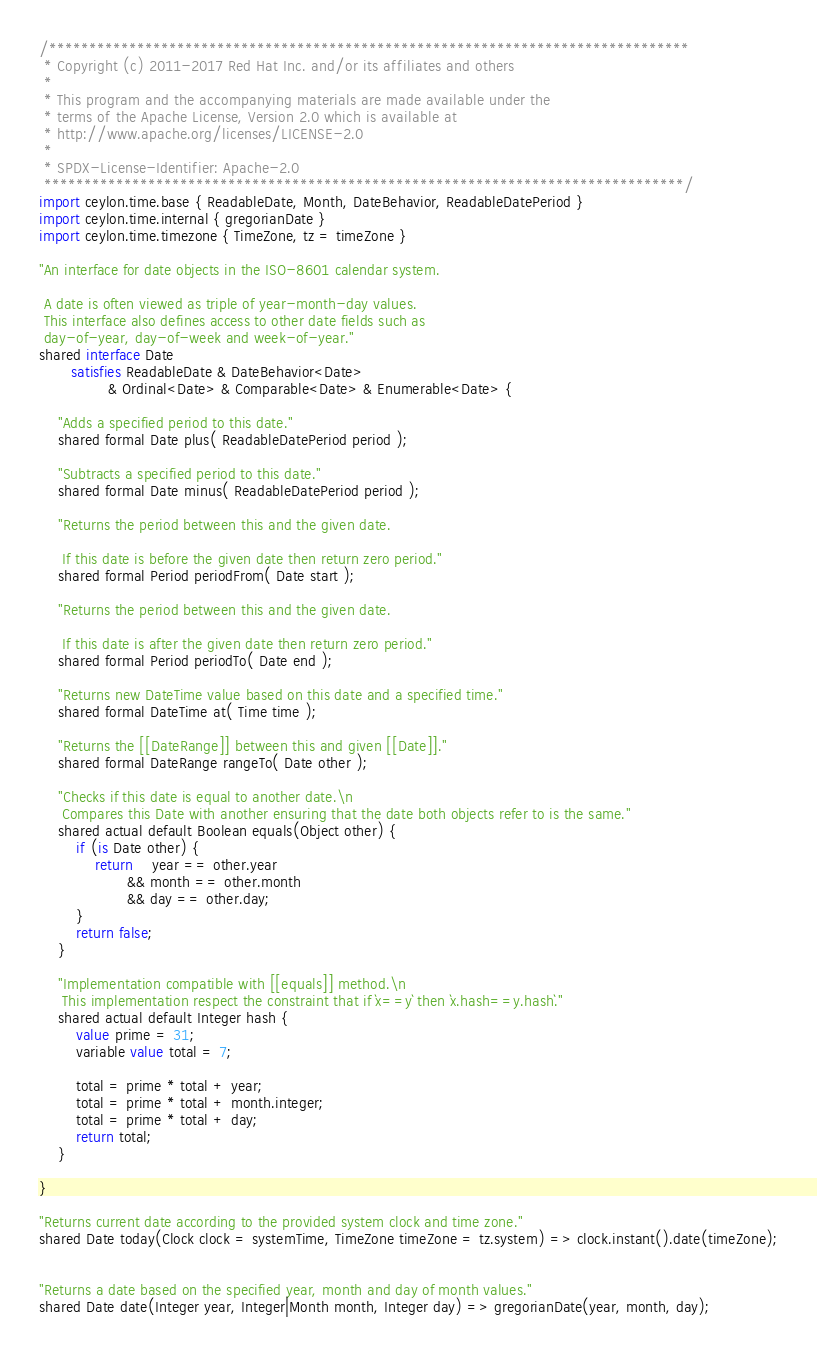<code> <loc_0><loc_0><loc_500><loc_500><_Ceylon_>/********************************************************************************
 * Copyright (c) 2011-2017 Red Hat Inc. and/or its affiliates and others
 *
 * This program and the accompanying materials are made available under the 
 * terms of the Apache License, Version 2.0 which is available at
 * http://www.apache.org/licenses/LICENSE-2.0
 *
 * SPDX-License-Identifier: Apache-2.0 
 ********************************************************************************/
import ceylon.time.base { ReadableDate, Month, DateBehavior, ReadableDatePeriod }
import ceylon.time.internal { gregorianDate }
import ceylon.time.timezone { TimeZone, tz = timeZone }

"An interface for date objects in the ISO-8601 calendar system.
 
 A date is often viewed as triple of year-month-day values. 
 This interface also defines access to other date fields such as 
 day-of-year, day-of-week and week-of-year."
shared interface Date
       satisfies ReadableDate & DateBehavior<Date>
               & Ordinal<Date> & Comparable<Date> & Enumerable<Date> {

    "Adds a specified period to this date."
    shared formal Date plus( ReadableDatePeriod period );

    "Subtracts a specified period to this date."
    shared formal Date minus( ReadableDatePeriod period );

    "Returns the period between this and the given date.
     
     If this date is before the given date then return zero period."
    shared formal Period periodFrom( Date start );

    "Returns the period between this and the given date.
     
     If this date is after the given date then return zero period."
    shared formal Period periodTo( Date end );

    "Returns new DateTime value based on this date and a specified time."
    shared formal DateTime at( Time time );

    "Returns the [[DateRange]] between this and given [[Date]]."
    shared formal DateRange rangeTo( Date other );
    
    "Checks if this date is equal to another date.\n
     Compares this Date with another ensuring that the date both objects refer to is the same."
    shared actual default Boolean equals(Object other) {
        if (is Date other) {
            return    year == other.year 
                   && month == other.month 
                   && day == other.day;
        }
        return false;
    }
    
    "Implementation compatible with [[equals]] method.\n
     This implementation respect the constraint that if `x==y` then `x.hash==y.hash`."
    shared actual default Integer hash {
        value prime = 31;
        variable value total = 7;
        
        total = prime * total + year;
        total = prime * total + month.integer;
        total = prime * total + day;
        return total;
    }

}

"Returns current date according to the provided system clock and time zone."
shared Date today(Clock clock = systemTime, TimeZone timeZone = tz.system) => clock.instant().date(timeZone);


"Returns a date based on the specified year, month and day of month values."
shared Date date(Integer year, Integer|Month month, Integer day) => gregorianDate(year, month, day);

</code> 